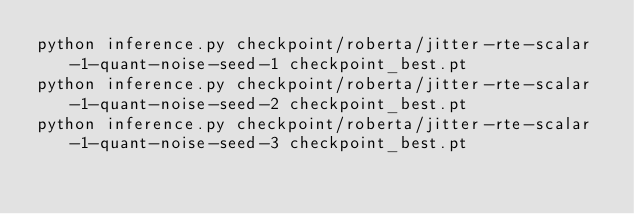<code> <loc_0><loc_0><loc_500><loc_500><_Bash_>python inference.py checkpoint/roberta/jitter-rte-scalar-1-quant-noise-seed-1 checkpoint_best.pt  
python inference.py checkpoint/roberta/jitter-rte-scalar-1-quant-noise-seed-2 checkpoint_best.pt  
python inference.py checkpoint/roberta/jitter-rte-scalar-1-quant-noise-seed-3 checkpoint_best.pt  
</code> 